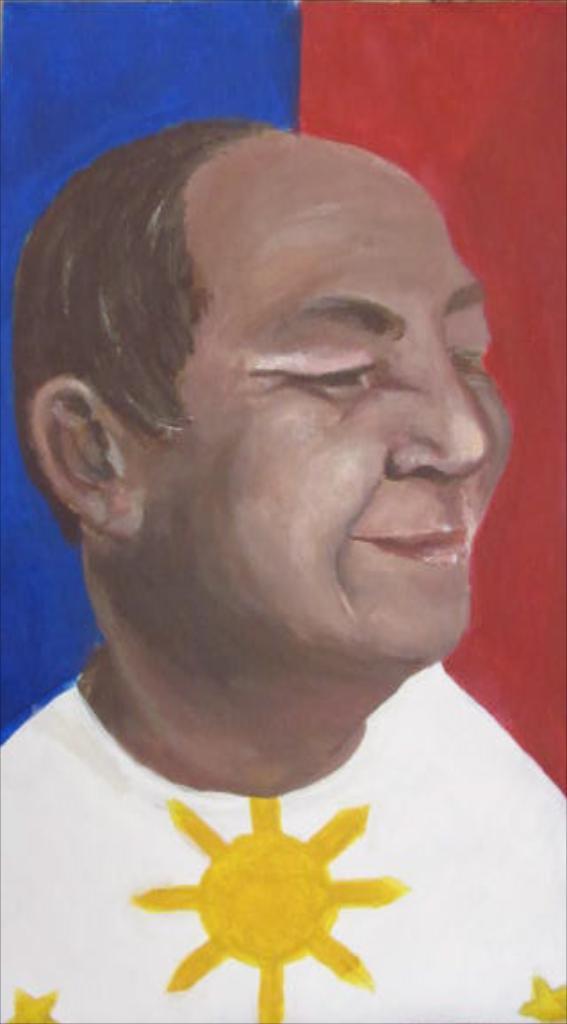How would you summarize this image in a sentence or two? In the image there is a painting of a person. 